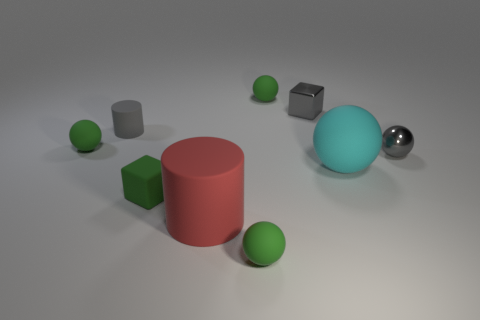Add 1 gray cylinders. How many objects exist? 10 Subtract all cyan balls. How many balls are left? 4 Subtract all cyan spheres. How many spheres are left? 4 Subtract all cylinders. How many objects are left? 7 Subtract 2 blocks. How many blocks are left? 0 Subtract 0 yellow cylinders. How many objects are left? 9 Subtract all brown cubes. Subtract all green cylinders. How many cubes are left? 2 Subtract all cyan balls. How many red cylinders are left? 1 Subtract all big cyan matte things. Subtract all large balls. How many objects are left? 7 Add 2 big matte cylinders. How many big matte cylinders are left? 3 